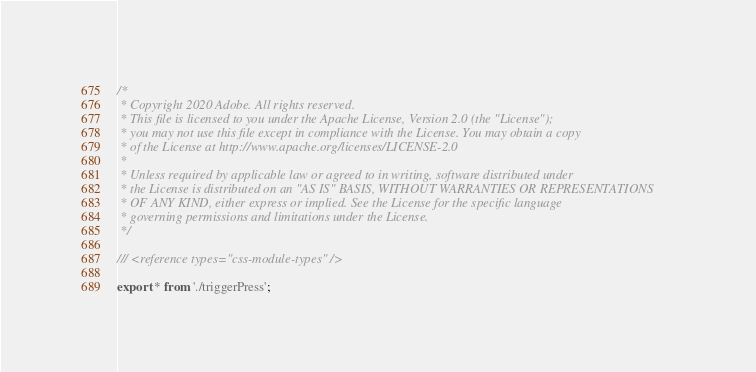Convert code to text. <code><loc_0><loc_0><loc_500><loc_500><_TypeScript_>/*
 * Copyright 2020 Adobe. All rights reserved.
 * This file is licensed to you under the Apache License, Version 2.0 (the "License");
 * you may not use this file except in compliance with the License. You may obtain a copy
 * of the License at http://www.apache.org/licenses/LICENSE-2.0
 *
 * Unless required by applicable law or agreed to in writing, software distributed under
 * the License is distributed on an "AS IS" BASIS, WITHOUT WARRANTIES OR REPRESENTATIONS
 * OF ANY KIND, either express or implied. See the License for the specific language
 * governing permissions and limitations under the License.
 */

/// <reference types="css-module-types" />

export * from './triggerPress';
</code> 